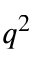<formula> <loc_0><loc_0><loc_500><loc_500>q ^ { 2 }</formula> 